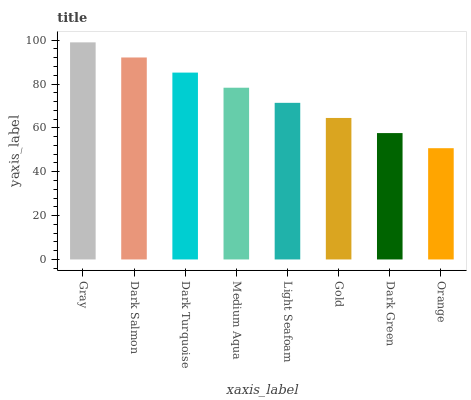Is Orange the minimum?
Answer yes or no. Yes. Is Gray the maximum?
Answer yes or no. Yes. Is Dark Salmon the minimum?
Answer yes or no. No. Is Dark Salmon the maximum?
Answer yes or no. No. Is Gray greater than Dark Salmon?
Answer yes or no. Yes. Is Dark Salmon less than Gray?
Answer yes or no. Yes. Is Dark Salmon greater than Gray?
Answer yes or no. No. Is Gray less than Dark Salmon?
Answer yes or no. No. Is Medium Aqua the high median?
Answer yes or no. Yes. Is Light Seafoam the low median?
Answer yes or no. Yes. Is Gold the high median?
Answer yes or no. No. Is Gold the low median?
Answer yes or no. No. 